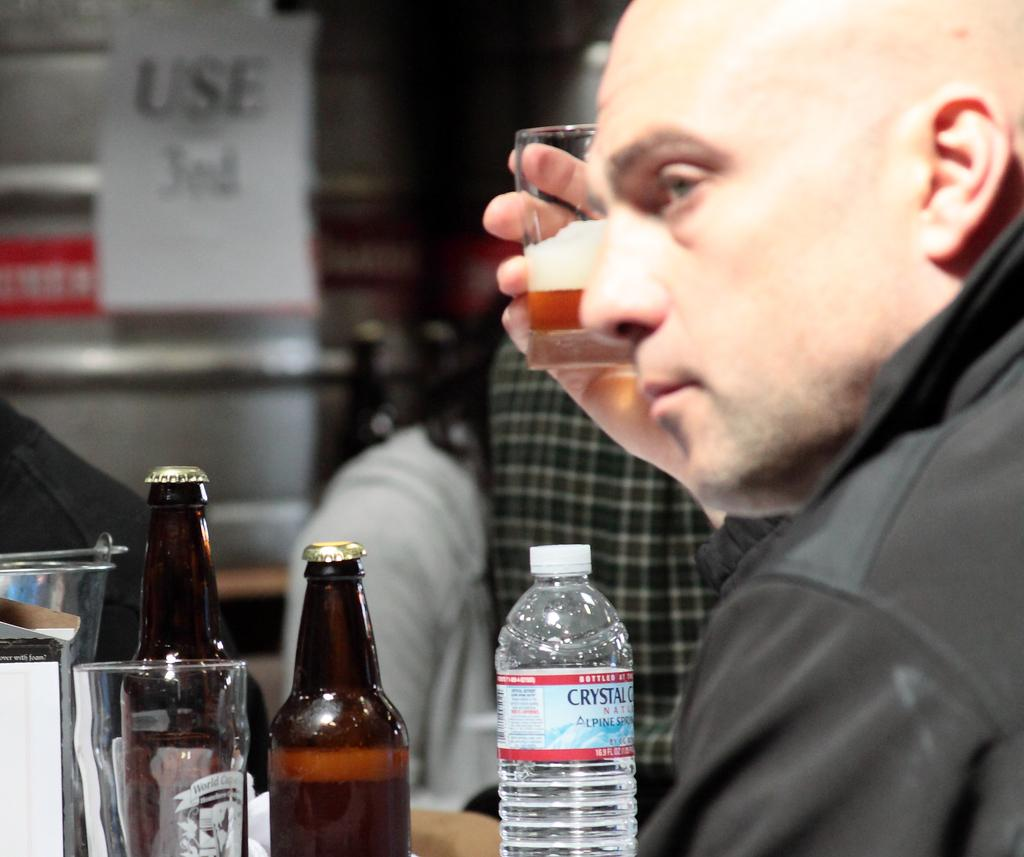<image>
Give a short and clear explanation of the subsequent image. A bald man holding a glass of beer with a bottle of Crystal water in front of him. 